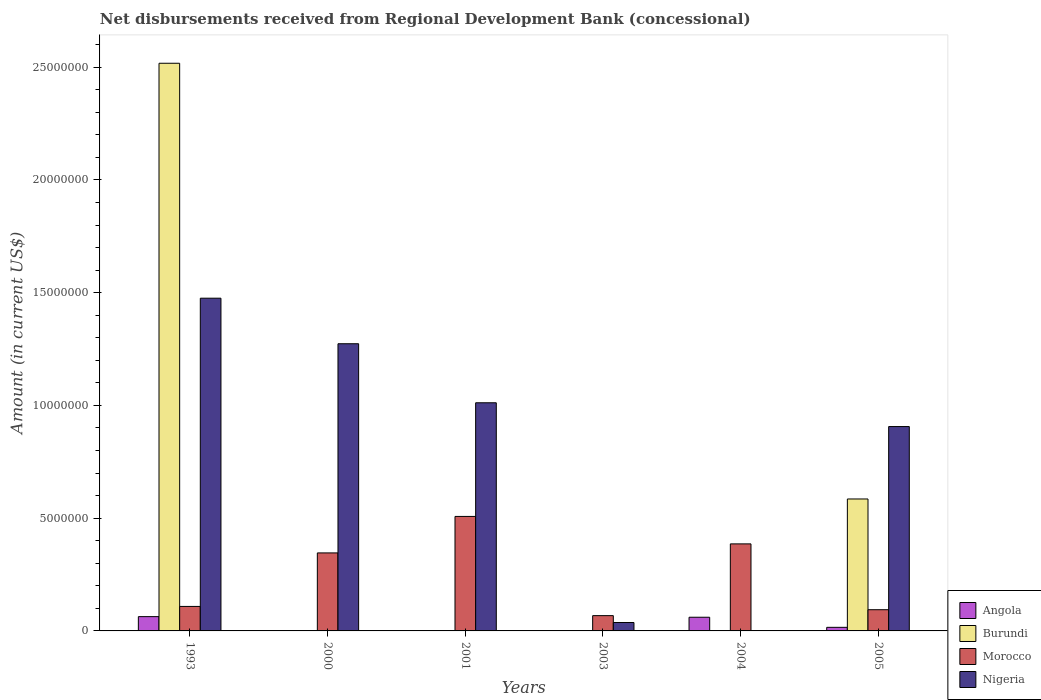How many different coloured bars are there?
Keep it short and to the point. 4. How many groups of bars are there?
Your answer should be very brief. 6. Are the number of bars per tick equal to the number of legend labels?
Ensure brevity in your answer.  No. How many bars are there on the 2nd tick from the left?
Your answer should be very brief. 2. Across all years, what is the maximum amount of disbursements received from Regional Development Bank in Angola?
Keep it short and to the point. 6.34e+05. Across all years, what is the minimum amount of disbursements received from Regional Development Bank in Angola?
Give a very brief answer. 0. What is the total amount of disbursements received from Regional Development Bank in Burundi in the graph?
Keep it short and to the point. 3.10e+07. What is the difference between the amount of disbursements received from Regional Development Bank in Nigeria in 2003 and that in 2005?
Keep it short and to the point. -8.69e+06. What is the difference between the amount of disbursements received from Regional Development Bank in Morocco in 2000 and the amount of disbursements received from Regional Development Bank in Burundi in 2004?
Provide a succinct answer. 3.46e+06. What is the average amount of disbursements received from Regional Development Bank in Angola per year?
Give a very brief answer. 2.33e+05. In the year 2004, what is the difference between the amount of disbursements received from Regional Development Bank in Angola and amount of disbursements received from Regional Development Bank in Morocco?
Your answer should be very brief. -3.25e+06. What is the ratio of the amount of disbursements received from Regional Development Bank in Nigeria in 1993 to that in 2001?
Your answer should be compact. 1.46. Is the difference between the amount of disbursements received from Regional Development Bank in Angola in 1993 and 2005 greater than the difference between the amount of disbursements received from Regional Development Bank in Morocco in 1993 and 2005?
Ensure brevity in your answer.  Yes. What is the difference between the highest and the second highest amount of disbursements received from Regional Development Bank in Angola?
Your answer should be very brief. 2.70e+04. What is the difference between the highest and the lowest amount of disbursements received from Regional Development Bank in Burundi?
Provide a succinct answer. 2.52e+07. In how many years, is the amount of disbursements received from Regional Development Bank in Angola greater than the average amount of disbursements received from Regional Development Bank in Angola taken over all years?
Your answer should be very brief. 2. Is it the case that in every year, the sum of the amount of disbursements received from Regional Development Bank in Morocco and amount of disbursements received from Regional Development Bank in Nigeria is greater than the amount of disbursements received from Regional Development Bank in Burundi?
Give a very brief answer. No. How many bars are there?
Your response must be concise. 16. How many years are there in the graph?
Your answer should be very brief. 6. Are the values on the major ticks of Y-axis written in scientific E-notation?
Offer a terse response. No. Does the graph contain grids?
Keep it short and to the point. No. How many legend labels are there?
Provide a succinct answer. 4. How are the legend labels stacked?
Offer a terse response. Vertical. What is the title of the graph?
Provide a short and direct response. Net disbursements received from Regional Development Bank (concessional). What is the Amount (in current US$) of Angola in 1993?
Offer a terse response. 6.34e+05. What is the Amount (in current US$) of Burundi in 1993?
Provide a succinct answer. 2.52e+07. What is the Amount (in current US$) of Morocco in 1993?
Give a very brief answer. 1.09e+06. What is the Amount (in current US$) in Nigeria in 1993?
Offer a very short reply. 1.48e+07. What is the Amount (in current US$) of Burundi in 2000?
Provide a short and direct response. 0. What is the Amount (in current US$) in Morocco in 2000?
Provide a succinct answer. 3.46e+06. What is the Amount (in current US$) of Nigeria in 2000?
Provide a short and direct response. 1.27e+07. What is the Amount (in current US$) in Angola in 2001?
Give a very brief answer. 0. What is the Amount (in current US$) of Morocco in 2001?
Provide a short and direct response. 5.08e+06. What is the Amount (in current US$) of Nigeria in 2001?
Make the answer very short. 1.01e+07. What is the Amount (in current US$) in Burundi in 2003?
Your answer should be very brief. 0. What is the Amount (in current US$) of Morocco in 2003?
Keep it short and to the point. 6.78e+05. What is the Amount (in current US$) of Nigeria in 2003?
Your answer should be compact. 3.73e+05. What is the Amount (in current US$) of Angola in 2004?
Offer a terse response. 6.07e+05. What is the Amount (in current US$) in Morocco in 2004?
Provide a succinct answer. 3.86e+06. What is the Amount (in current US$) in Angola in 2005?
Make the answer very short. 1.59e+05. What is the Amount (in current US$) in Burundi in 2005?
Offer a terse response. 5.85e+06. What is the Amount (in current US$) in Morocco in 2005?
Provide a short and direct response. 9.41e+05. What is the Amount (in current US$) in Nigeria in 2005?
Make the answer very short. 9.06e+06. Across all years, what is the maximum Amount (in current US$) in Angola?
Provide a succinct answer. 6.34e+05. Across all years, what is the maximum Amount (in current US$) of Burundi?
Your answer should be compact. 2.52e+07. Across all years, what is the maximum Amount (in current US$) in Morocco?
Make the answer very short. 5.08e+06. Across all years, what is the maximum Amount (in current US$) of Nigeria?
Make the answer very short. 1.48e+07. Across all years, what is the minimum Amount (in current US$) in Angola?
Make the answer very short. 0. Across all years, what is the minimum Amount (in current US$) in Morocco?
Keep it short and to the point. 6.78e+05. Across all years, what is the minimum Amount (in current US$) in Nigeria?
Provide a short and direct response. 0. What is the total Amount (in current US$) in Angola in the graph?
Ensure brevity in your answer.  1.40e+06. What is the total Amount (in current US$) in Burundi in the graph?
Your answer should be very brief. 3.10e+07. What is the total Amount (in current US$) in Morocco in the graph?
Ensure brevity in your answer.  1.51e+07. What is the total Amount (in current US$) in Nigeria in the graph?
Your answer should be compact. 4.70e+07. What is the difference between the Amount (in current US$) in Morocco in 1993 and that in 2000?
Your answer should be very brief. -2.37e+06. What is the difference between the Amount (in current US$) of Nigeria in 1993 and that in 2000?
Provide a succinct answer. 2.02e+06. What is the difference between the Amount (in current US$) of Morocco in 1993 and that in 2001?
Your answer should be compact. -3.99e+06. What is the difference between the Amount (in current US$) in Nigeria in 1993 and that in 2001?
Your answer should be compact. 4.64e+06. What is the difference between the Amount (in current US$) in Morocco in 1993 and that in 2003?
Keep it short and to the point. 4.08e+05. What is the difference between the Amount (in current US$) of Nigeria in 1993 and that in 2003?
Give a very brief answer. 1.44e+07. What is the difference between the Amount (in current US$) in Angola in 1993 and that in 2004?
Your response must be concise. 2.70e+04. What is the difference between the Amount (in current US$) in Morocco in 1993 and that in 2004?
Your answer should be compact. -2.77e+06. What is the difference between the Amount (in current US$) in Angola in 1993 and that in 2005?
Give a very brief answer. 4.75e+05. What is the difference between the Amount (in current US$) of Burundi in 1993 and that in 2005?
Give a very brief answer. 1.93e+07. What is the difference between the Amount (in current US$) of Morocco in 1993 and that in 2005?
Ensure brevity in your answer.  1.45e+05. What is the difference between the Amount (in current US$) in Nigeria in 1993 and that in 2005?
Provide a succinct answer. 5.69e+06. What is the difference between the Amount (in current US$) in Morocco in 2000 and that in 2001?
Keep it short and to the point. -1.62e+06. What is the difference between the Amount (in current US$) of Nigeria in 2000 and that in 2001?
Your answer should be compact. 2.62e+06. What is the difference between the Amount (in current US$) of Morocco in 2000 and that in 2003?
Your response must be concise. 2.78e+06. What is the difference between the Amount (in current US$) of Nigeria in 2000 and that in 2003?
Your answer should be very brief. 1.24e+07. What is the difference between the Amount (in current US$) in Morocco in 2000 and that in 2004?
Give a very brief answer. -4.00e+05. What is the difference between the Amount (in current US$) in Morocco in 2000 and that in 2005?
Your answer should be compact. 2.52e+06. What is the difference between the Amount (in current US$) in Nigeria in 2000 and that in 2005?
Provide a succinct answer. 3.67e+06. What is the difference between the Amount (in current US$) of Morocco in 2001 and that in 2003?
Keep it short and to the point. 4.40e+06. What is the difference between the Amount (in current US$) of Nigeria in 2001 and that in 2003?
Make the answer very short. 9.75e+06. What is the difference between the Amount (in current US$) of Morocco in 2001 and that in 2004?
Offer a terse response. 1.22e+06. What is the difference between the Amount (in current US$) in Morocco in 2001 and that in 2005?
Give a very brief answer. 4.14e+06. What is the difference between the Amount (in current US$) in Nigeria in 2001 and that in 2005?
Your response must be concise. 1.06e+06. What is the difference between the Amount (in current US$) of Morocco in 2003 and that in 2004?
Offer a very short reply. -3.18e+06. What is the difference between the Amount (in current US$) in Morocco in 2003 and that in 2005?
Provide a short and direct response. -2.63e+05. What is the difference between the Amount (in current US$) of Nigeria in 2003 and that in 2005?
Keep it short and to the point. -8.69e+06. What is the difference between the Amount (in current US$) in Angola in 2004 and that in 2005?
Your answer should be compact. 4.48e+05. What is the difference between the Amount (in current US$) in Morocco in 2004 and that in 2005?
Your response must be concise. 2.92e+06. What is the difference between the Amount (in current US$) in Angola in 1993 and the Amount (in current US$) in Morocco in 2000?
Provide a succinct answer. -2.83e+06. What is the difference between the Amount (in current US$) in Angola in 1993 and the Amount (in current US$) in Nigeria in 2000?
Offer a very short reply. -1.21e+07. What is the difference between the Amount (in current US$) in Burundi in 1993 and the Amount (in current US$) in Morocco in 2000?
Your response must be concise. 2.17e+07. What is the difference between the Amount (in current US$) in Burundi in 1993 and the Amount (in current US$) in Nigeria in 2000?
Keep it short and to the point. 1.24e+07. What is the difference between the Amount (in current US$) in Morocco in 1993 and the Amount (in current US$) in Nigeria in 2000?
Give a very brief answer. -1.17e+07. What is the difference between the Amount (in current US$) in Angola in 1993 and the Amount (in current US$) in Morocco in 2001?
Give a very brief answer. -4.44e+06. What is the difference between the Amount (in current US$) of Angola in 1993 and the Amount (in current US$) of Nigeria in 2001?
Keep it short and to the point. -9.48e+06. What is the difference between the Amount (in current US$) in Burundi in 1993 and the Amount (in current US$) in Morocco in 2001?
Make the answer very short. 2.01e+07. What is the difference between the Amount (in current US$) in Burundi in 1993 and the Amount (in current US$) in Nigeria in 2001?
Provide a short and direct response. 1.51e+07. What is the difference between the Amount (in current US$) in Morocco in 1993 and the Amount (in current US$) in Nigeria in 2001?
Offer a very short reply. -9.03e+06. What is the difference between the Amount (in current US$) in Angola in 1993 and the Amount (in current US$) in Morocco in 2003?
Your answer should be very brief. -4.40e+04. What is the difference between the Amount (in current US$) of Angola in 1993 and the Amount (in current US$) of Nigeria in 2003?
Provide a short and direct response. 2.61e+05. What is the difference between the Amount (in current US$) in Burundi in 1993 and the Amount (in current US$) in Morocco in 2003?
Your answer should be very brief. 2.45e+07. What is the difference between the Amount (in current US$) of Burundi in 1993 and the Amount (in current US$) of Nigeria in 2003?
Keep it short and to the point. 2.48e+07. What is the difference between the Amount (in current US$) in Morocco in 1993 and the Amount (in current US$) in Nigeria in 2003?
Ensure brevity in your answer.  7.13e+05. What is the difference between the Amount (in current US$) of Angola in 1993 and the Amount (in current US$) of Morocco in 2004?
Your answer should be compact. -3.23e+06. What is the difference between the Amount (in current US$) in Burundi in 1993 and the Amount (in current US$) in Morocco in 2004?
Provide a succinct answer. 2.13e+07. What is the difference between the Amount (in current US$) of Angola in 1993 and the Amount (in current US$) of Burundi in 2005?
Your response must be concise. -5.22e+06. What is the difference between the Amount (in current US$) in Angola in 1993 and the Amount (in current US$) in Morocco in 2005?
Ensure brevity in your answer.  -3.07e+05. What is the difference between the Amount (in current US$) of Angola in 1993 and the Amount (in current US$) of Nigeria in 2005?
Make the answer very short. -8.43e+06. What is the difference between the Amount (in current US$) in Burundi in 1993 and the Amount (in current US$) in Morocco in 2005?
Your response must be concise. 2.42e+07. What is the difference between the Amount (in current US$) of Burundi in 1993 and the Amount (in current US$) of Nigeria in 2005?
Your response must be concise. 1.61e+07. What is the difference between the Amount (in current US$) in Morocco in 1993 and the Amount (in current US$) in Nigeria in 2005?
Your response must be concise. -7.98e+06. What is the difference between the Amount (in current US$) in Morocco in 2000 and the Amount (in current US$) in Nigeria in 2001?
Offer a terse response. -6.66e+06. What is the difference between the Amount (in current US$) in Morocco in 2000 and the Amount (in current US$) in Nigeria in 2003?
Make the answer very short. 3.09e+06. What is the difference between the Amount (in current US$) in Morocco in 2000 and the Amount (in current US$) in Nigeria in 2005?
Provide a succinct answer. -5.60e+06. What is the difference between the Amount (in current US$) in Morocco in 2001 and the Amount (in current US$) in Nigeria in 2003?
Ensure brevity in your answer.  4.70e+06. What is the difference between the Amount (in current US$) of Morocco in 2001 and the Amount (in current US$) of Nigeria in 2005?
Offer a terse response. -3.99e+06. What is the difference between the Amount (in current US$) in Morocco in 2003 and the Amount (in current US$) in Nigeria in 2005?
Provide a short and direct response. -8.39e+06. What is the difference between the Amount (in current US$) of Angola in 2004 and the Amount (in current US$) of Burundi in 2005?
Offer a very short reply. -5.24e+06. What is the difference between the Amount (in current US$) of Angola in 2004 and the Amount (in current US$) of Morocco in 2005?
Give a very brief answer. -3.34e+05. What is the difference between the Amount (in current US$) in Angola in 2004 and the Amount (in current US$) in Nigeria in 2005?
Your answer should be very brief. -8.46e+06. What is the difference between the Amount (in current US$) in Morocco in 2004 and the Amount (in current US$) in Nigeria in 2005?
Offer a terse response. -5.20e+06. What is the average Amount (in current US$) in Angola per year?
Your response must be concise. 2.33e+05. What is the average Amount (in current US$) in Burundi per year?
Keep it short and to the point. 5.17e+06. What is the average Amount (in current US$) of Morocco per year?
Ensure brevity in your answer.  2.52e+06. What is the average Amount (in current US$) in Nigeria per year?
Your answer should be very brief. 7.84e+06. In the year 1993, what is the difference between the Amount (in current US$) in Angola and Amount (in current US$) in Burundi?
Make the answer very short. -2.45e+07. In the year 1993, what is the difference between the Amount (in current US$) in Angola and Amount (in current US$) in Morocco?
Give a very brief answer. -4.52e+05. In the year 1993, what is the difference between the Amount (in current US$) of Angola and Amount (in current US$) of Nigeria?
Provide a succinct answer. -1.41e+07. In the year 1993, what is the difference between the Amount (in current US$) of Burundi and Amount (in current US$) of Morocco?
Make the answer very short. 2.41e+07. In the year 1993, what is the difference between the Amount (in current US$) of Burundi and Amount (in current US$) of Nigeria?
Offer a very short reply. 1.04e+07. In the year 1993, what is the difference between the Amount (in current US$) in Morocco and Amount (in current US$) in Nigeria?
Your answer should be very brief. -1.37e+07. In the year 2000, what is the difference between the Amount (in current US$) of Morocco and Amount (in current US$) of Nigeria?
Keep it short and to the point. -9.28e+06. In the year 2001, what is the difference between the Amount (in current US$) of Morocco and Amount (in current US$) of Nigeria?
Ensure brevity in your answer.  -5.04e+06. In the year 2003, what is the difference between the Amount (in current US$) in Morocco and Amount (in current US$) in Nigeria?
Your answer should be compact. 3.05e+05. In the year 2004, what is the difference between the Amount (in current US$) in Angola and Amount (in current US$) in Morocco?
Provide a succinct answer. -3.25e+06. In the year 2005, what is the difference between the Amount (in current US$) of Angola and Amount (in current US$) of Burundi?
Your response must be concise. -5.69e+06. In the year 2005, what is the difference between the Amount (in current US$) of Angola and Amount (in current US$) of Morocco?
Offer a very short reply. -7.82e+05. In the year 2005, what is the difference between the Amount (in current US$) of Angola and Amount (in current US$) of Nigeria?
Keep it short and to the point. -8.90e+06. In the year 2005, what is the difference between the Amount (in current US$) of Burundi and Amount (in current US$) of Morocco?
Ensure brevity in your answer.  4.91e+06. In the year 2005, what is the difference between the Amount (in current US$) of Burundi and Amount (in current US$) of Nigeria?
Offer a terse response. -3.21e+06. In the year 2005, what is the difference between the Amount (in current US$) in Morocco and Amount (in current US$) in Nigeria?
Provide a succinct answer. -8.12e+06. What is the ratio of the Amount (in current US$) in Morocco in 1993 to that in 2000?
Offer a very short reply. 0.31. What is the ratio of the Amount (in current US$) in Nigeria in 1993 to that in 2000?
Your answer should be very brief. 1.16. What is the ratio of the Amount (in current US$) of Morocco in 1993 to that in 2001?
Provide a succinct answer. 0.21. What is the ratio of the Amount (in current US$) in Nigeria in 1993 to that in 2001?
Your answer should be very brief. 1.46. What is the ratio of the Amount (in current US$) in Morocco in 1993 to that in 2003?
Keep it short and to the point. 1.6. What is the ratio of the Amount (in current US$) of Nigeria in 1993 to that in 2003?
Provide a short and direct response. 39.56. What is the ratio of the Amount (in current US$) of Angola in 1993 to that in 2004?
Make the answer very short. 1.04. What is the ratio of the Amount (in current US$) of Morocco in 1993 to that in 2004?
Make the answer very short. 0.28. What is the ratio of the Amount (in current US$) in Angola in 1993 to that in 2005?
Your response must be concise. 3.99. What is the ratio of the Amount (in current US$) in Burundi in 1993 to that in 2005?
Give a very brief answer. 4.3. What is the ratio of the Amount (in current US$) in Morocco in 1993 to that in 2005?
Ensure brevity in your answer.  1.15. What is the ratio of the Amount (in current US$) of Nigeria in 1993 to that in 2005?
Your answer should be very brief. 1.63. What is the ratio of the Amount (in current US$) of Morocco in 2000 to that in 2001?
Offer a very short reply. 0.68. What is the ratio of the Amount (in current US$) of Nigeria in 2000 to that in 2001?
Make the answer very short. 1.26. What is the ratio of the Amount (in current US$) of Morocco in 2000 to that in 2003?
Ensure brevity in your answer.  5.1. What is the ratio of the Amount (in current US$) in Nigeria in 2000 to that in 2003?
Ensure brevity in your answer.  34.15. What is the ratio of the Amount (in current US$) in Morocco in 2000 to that in 2004?
Your answer should be very brief. 0.9. What is the ratio of the Amount (in current US$) in Morocco in 2000 to that in 2005?
Make the answer very short. 3.68. What is the ratio of the Amount (in current US$) of Nigeria in 2000 to that in 2005?
Offer a terse response. 1.41. What is the ratio of the Amount (in current US$) of Morocco in 2001 to that in 2003?
Your answer should be very brief. 7.49. What is the ratio of the Amount (in current US$) in Nigeria in 2001 to that in 2003?
Offer a very short reply. 27.13. What is the ratio of the Amount (in current US$) in Morocco in 2001 to that in 2004?
Your answer should be very brief. 1.32. What is the ratio of the Amount (in current US$) of Morocco in 2001 to that in 2005?
Your response must be concise. 5.4. What is the ratio of the Amount (in current US$) of Nigeria in 2001 to that in 2005?
Offer a terse response. 1.12. What is the ratio of the Amount (in current US$) of Morocco in 2003 to that in 2004?
Give a very brief answer. 0.18. What is the ratio of the Amount (in current US$) in Morocco in 2003 to that in 2005?
Ensure brevity in your answer.  0.72. What is the ratio of the Amount (in current US$) in Nigeria in 2003 to that in 2005?
Offer a very short reply. 0.04. What is the ratio of the Amount (in current US$) in Angola in 2004 to that in 2005?
Make the answer very short. 3.82. What is the ratio of the Amount (in current US$) in Morocco in 2004 to that in 2005?
Your answer should be compact. 4.1. What is the difference between the highest and the second highest Amount (in current US$) of Angola?
Your answer should be very brief. 2.70e+04. What is the difference between the highest and the second highest Amount (in current US$) of Morocco?
Provide a short and direct response. 1.22e+06. What is the difference between the highest and the second highest Amount (in current US$) in Nigeria?
Offer a very short reply. 2.02e+06. What is the difference between the highest and the lowest Amount (in current US$) in Angola?
Your answer should be compact. 6.34e+05. What is the difference between the highest and the lowest Amount (in current US$) in Burundi?
Your answer should be very brief. 2.52e+07. What is the difference between the highest and the lowest Amount (in current US$) in Morocco?
Your answer should be very brief. 4.40e+06. What is the difference between the highest and the lowest Amount (in current US$) in Nigeria?
Your response must be concise. 1.48e+07. 